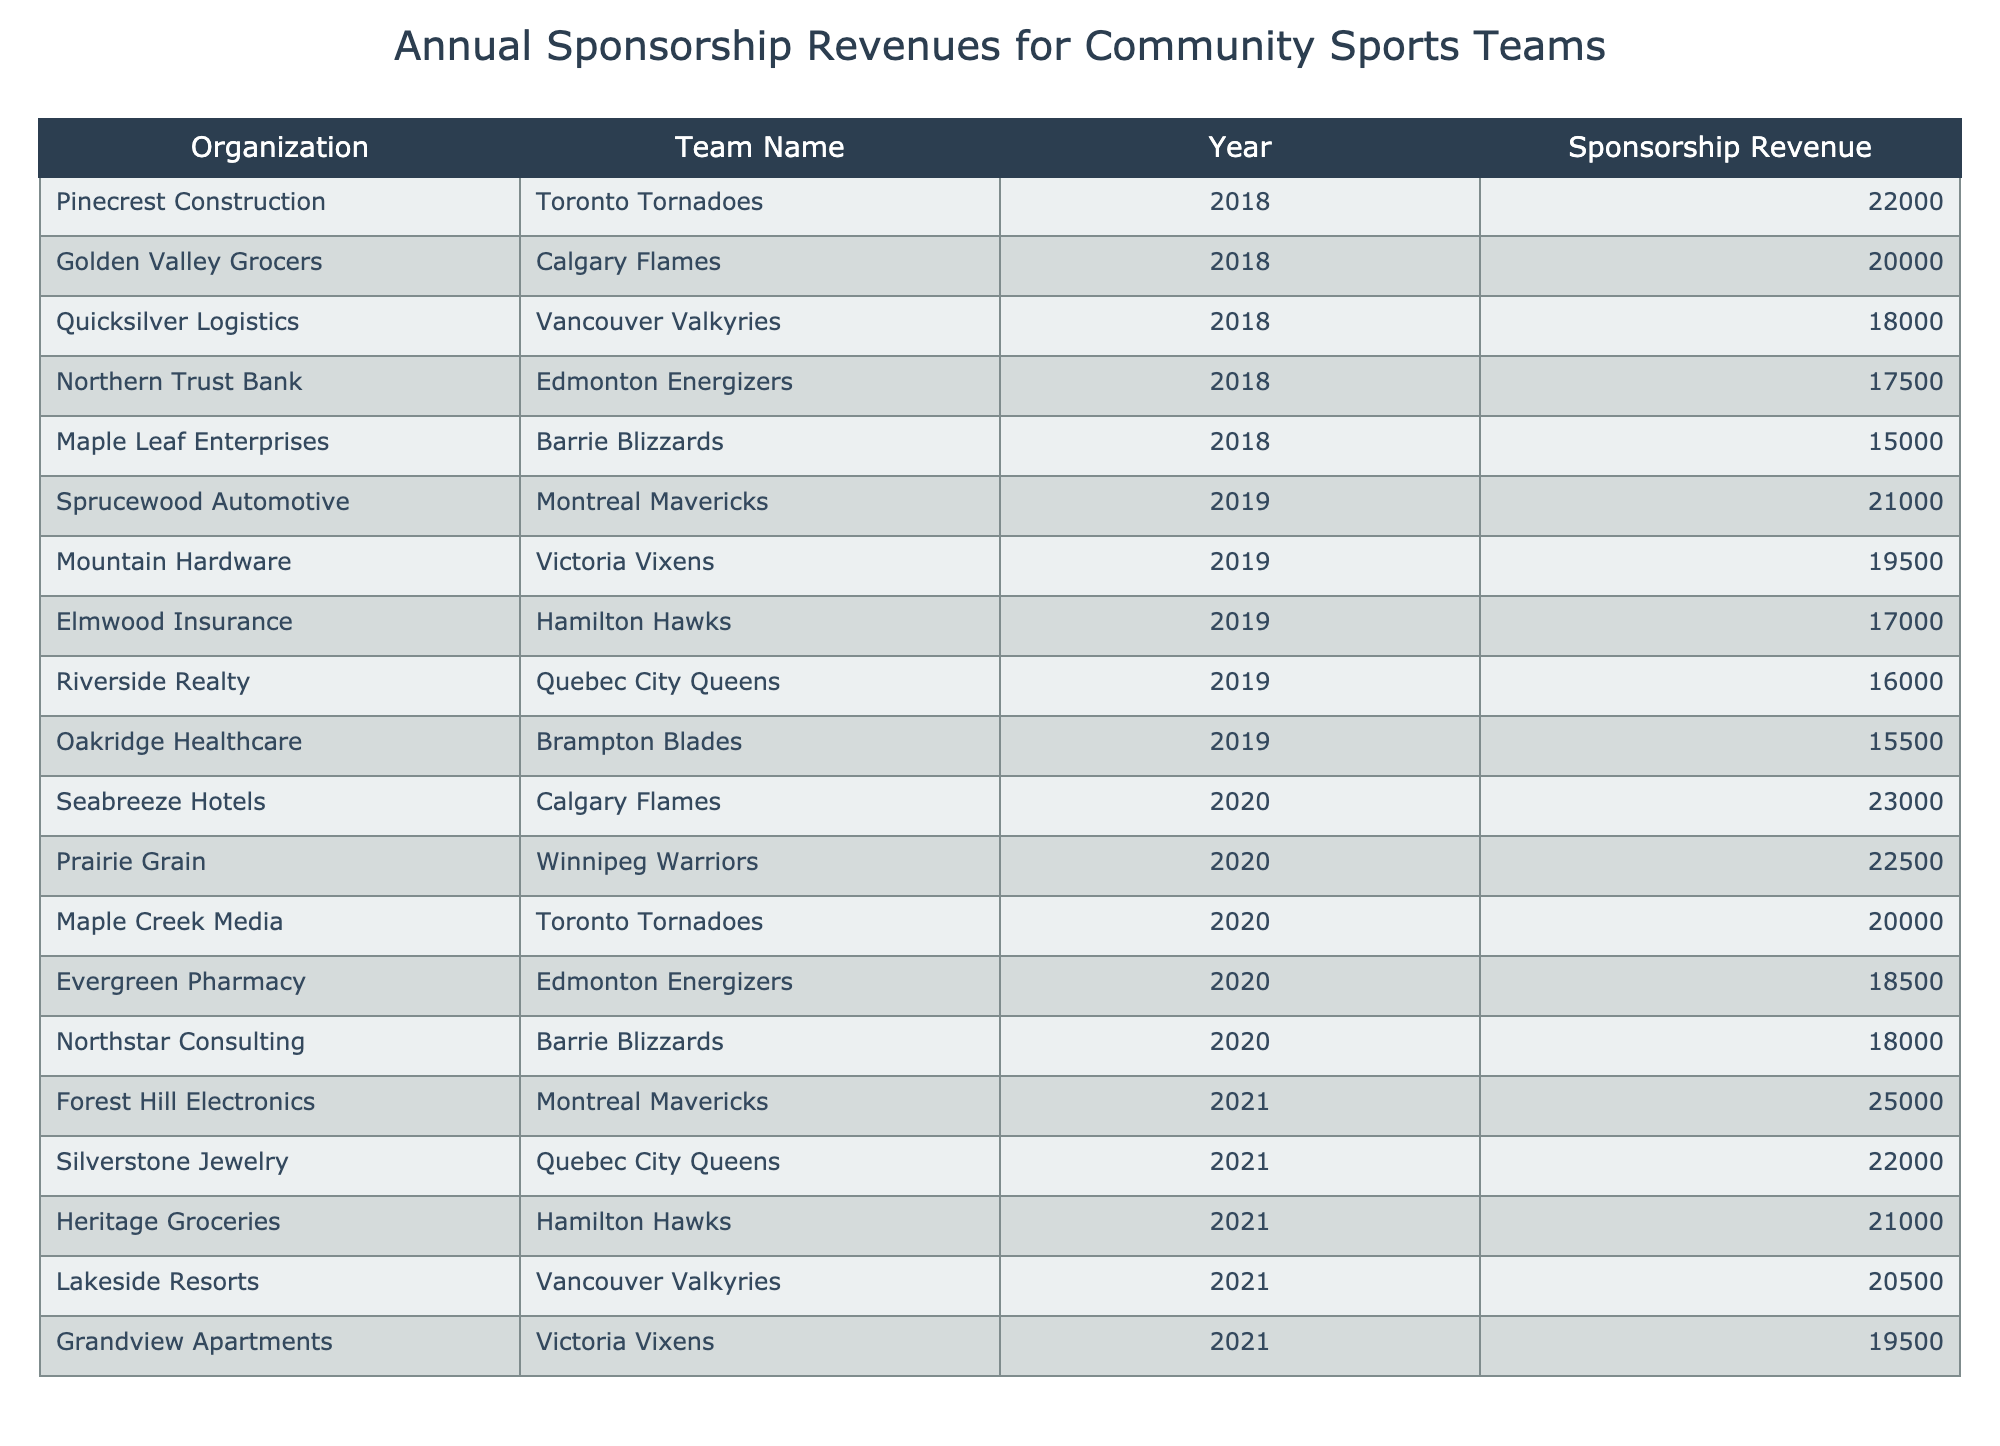What was the highest sponsorship revenue recorded for the Toronto Tornadoes? The Toronto Tornadoes earned sponsorship revenues of 22,000 in 2018 and 20,000 in 2020. The higher value is 22,000.
Answer: 22,000 Which team had the lowest sponsorship revenue in 2019? In 2019, the sponsorship revenues for the teams were as follows: Brampton Blades 15,500, Montreal Mavericks 21,000, Quebec City Queens 16,000, Victoria Vixens 19,500, Hamilton Hawks 17,000. The lowest value is 15,500 for the Brampton Blades.
Answer: 15,500 Was there a year when the Calgary Flames had revenue greater than 25,000? In 2018, the Calgary Flames had 20,000 and in 2020, they had 23,000. Neither of these values exceed 25,000, so the answer is no.
Answer: No What is the total sponsorship revenue for the Edmonton Energizers across all years? The Edmonton Energizers had sponsorship revenues of 17,500 in 2018, 18,500 in 2020. The total is 17,500 + 18,500 = 36,000.
Answer: 36,000 Which organization provided sponsorship for the Montreal Mavericks in 2021? According to the table, the organization that sponsored the Montreal Mavericks in 2021 was Forest Hill Electronics.
Answer: Forest Hill Electronics What was the average sponsorship revenue for the Brampton Blades over the years? The Brampton Blades received 15,500 in 2019. Since that's their only entry in the data, the average revenue is simply 15,500.
Answer: 15,500 Did the sponsorship revenue for the Victoria Vixens increase from 2019 to 2021? The Victoria Vixens had sponsorship revenues of 19,500 in 2019 and 19,500 in 2021, hence there was no increase.
Answer: No Which team received the most consistent sponsorship revenues from 2018 to 2021? The Toronto Tornadoes had sponsorship of 22,000 in 2018 and 20,000 in 2020. The variation between the years indicates consistency as it only dropped slightly. Other teams fluctuated more.
Answer: Toronto Tornadoes 